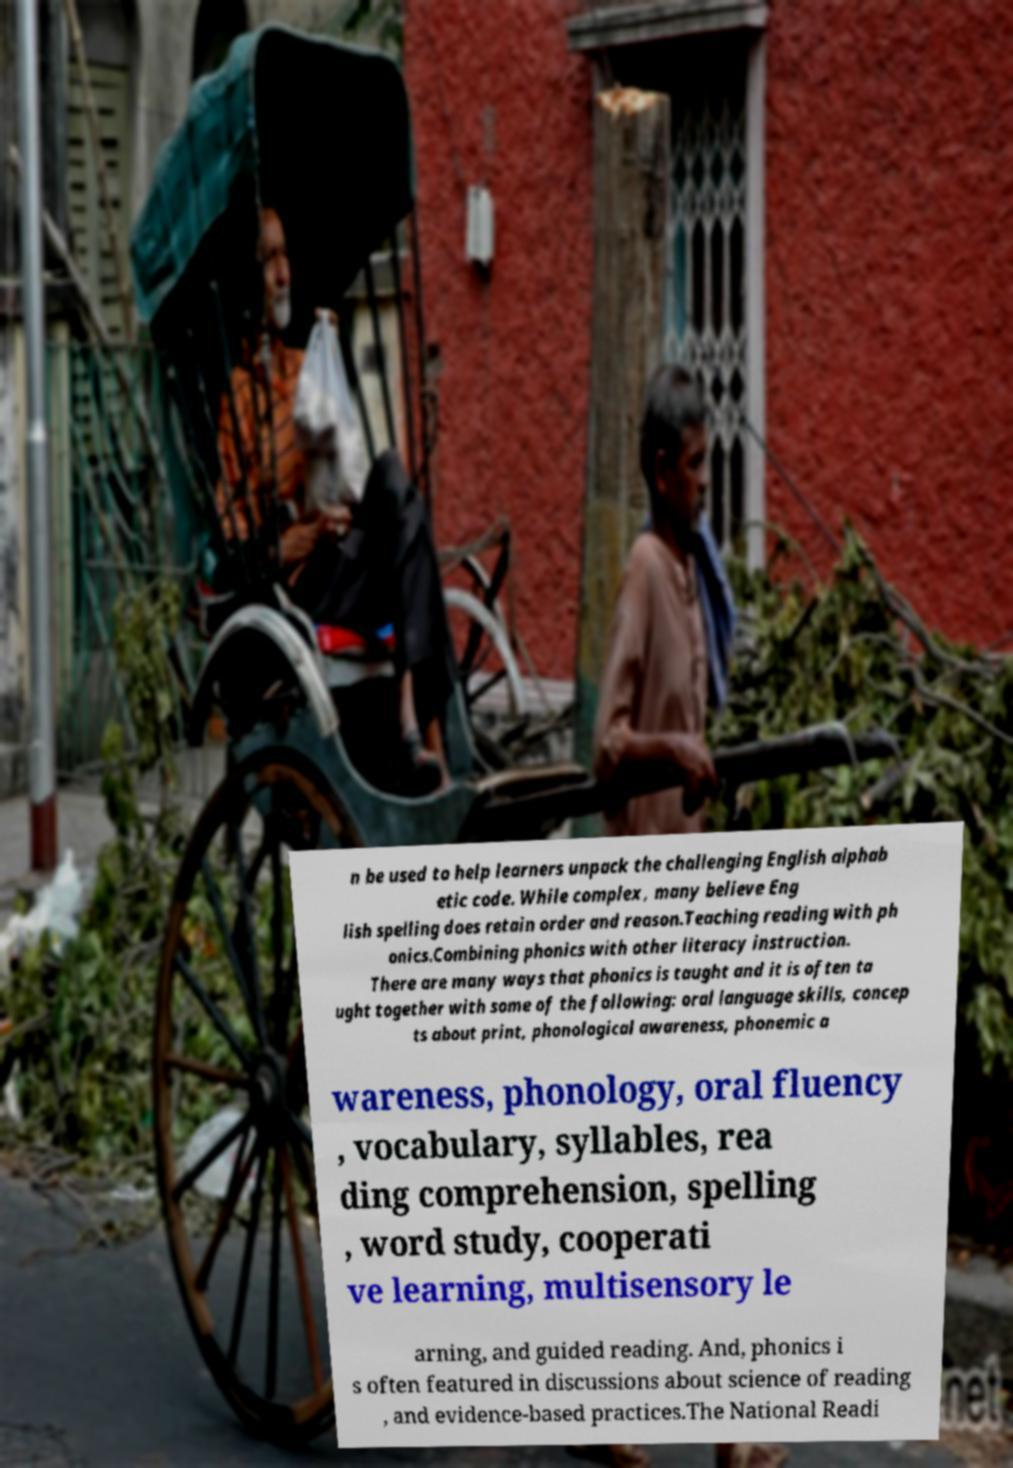Please identify and transcribe the text found in this image. n be used to help learners unpack the challenging English alphab etic code. While complex, many believe Eng lish spelling does retain order and reason.Teaching reading with ph onics.Combining phonics with other literacy instruction. There are many ways that phonics is taught and it is often ta ught together with some of the following: oral language skills, concep ts about print, phonological awareness, phonemic a wareness, phonology, oral fluency , vocabulary, syllables, rea ding comprehension, spelling , word study, cooperati ve learning, multisensory le arning, and guided reading. And, phonics i s often featured in discussions about science of reading , and evidence-based practices.The National Readi 